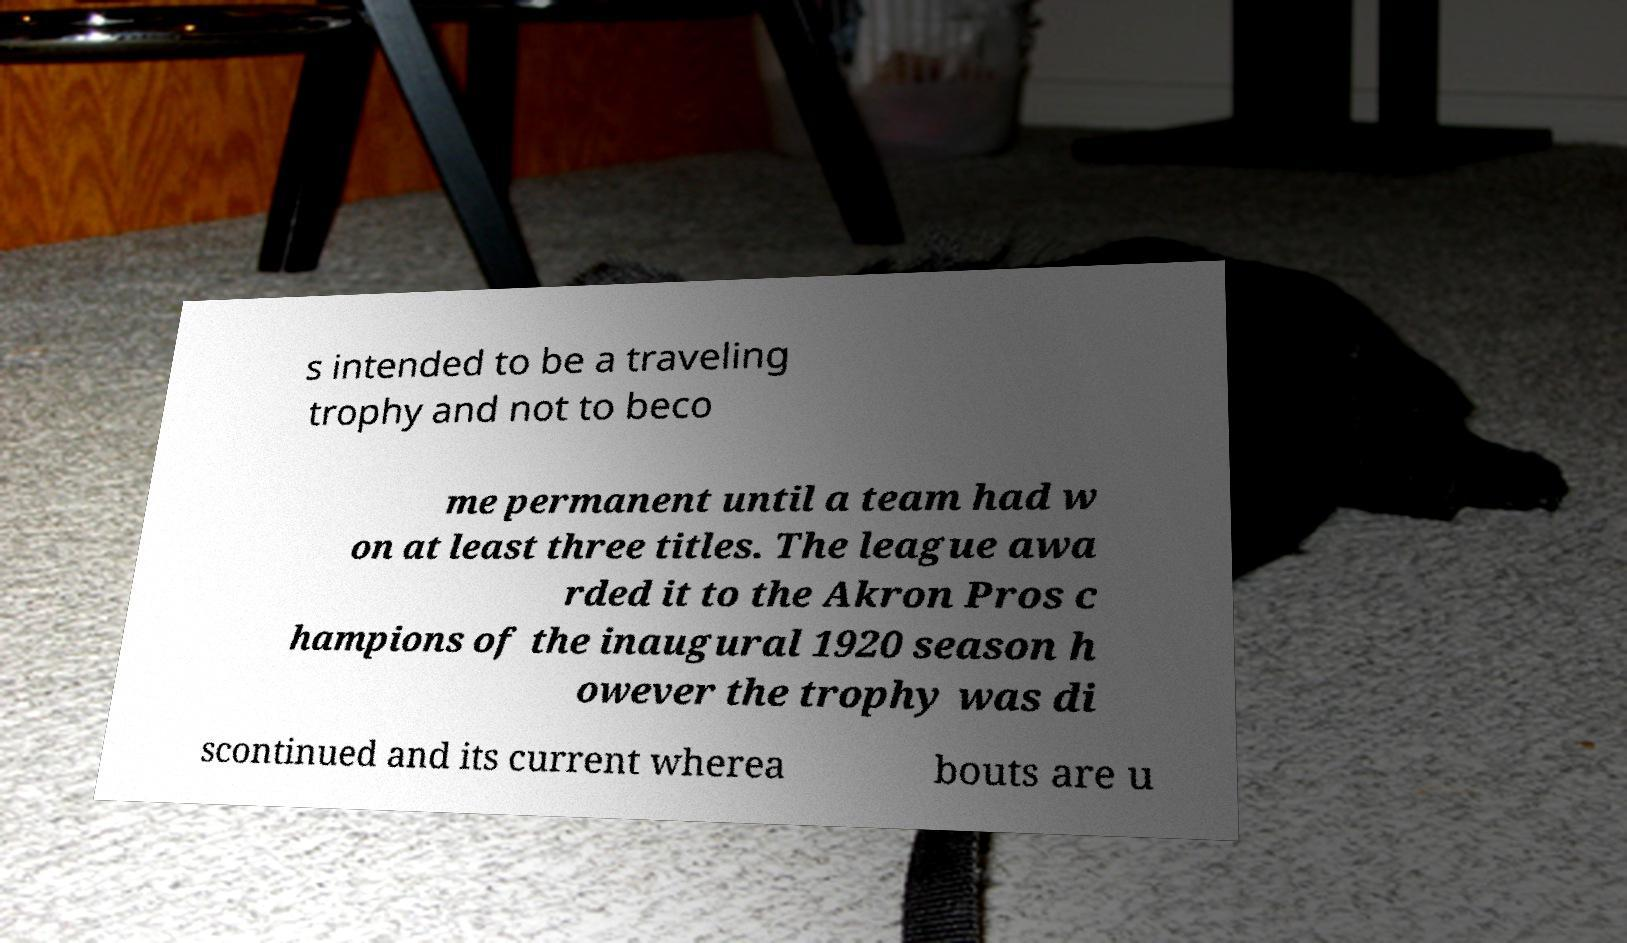Could you assist in decoding the text presented in this image and type it out clearly? s intended to be a traveling trophy and not to beco me permanent until a team had w on at least three titles. The league awa rded it to the Akron Pros c hampions of the inaugural 1920 season h owever the trophy was di scontinued and its current wherea bouts are u 